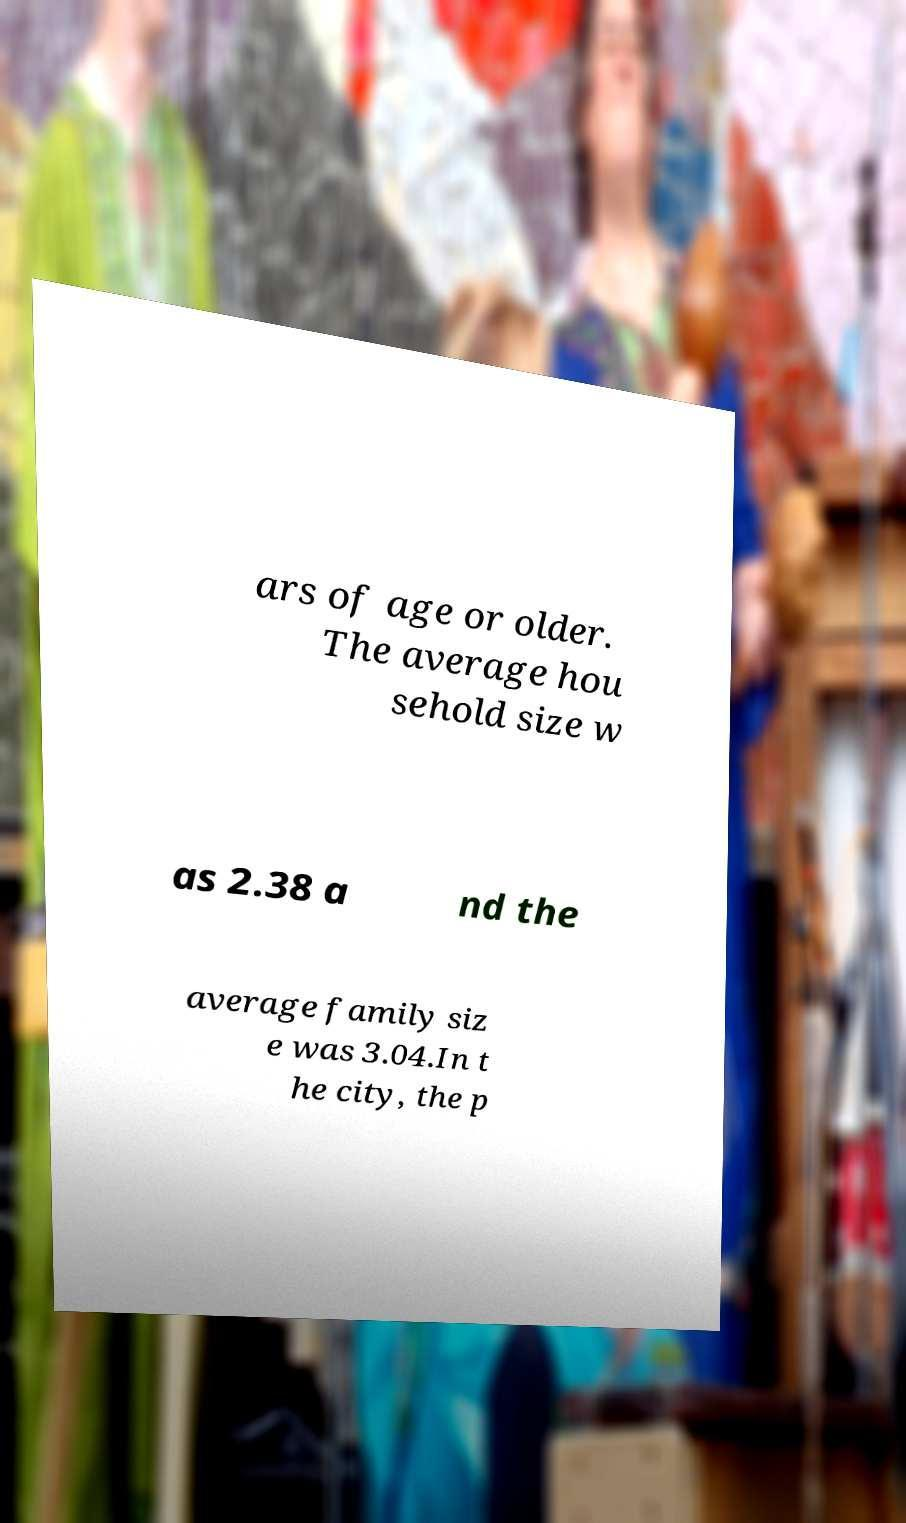Could you extract and type out the text from this image? ars of age or older. The average hou sehold size w as 2.38 a nd the average family siz e was 3.04.In t he city, the p 